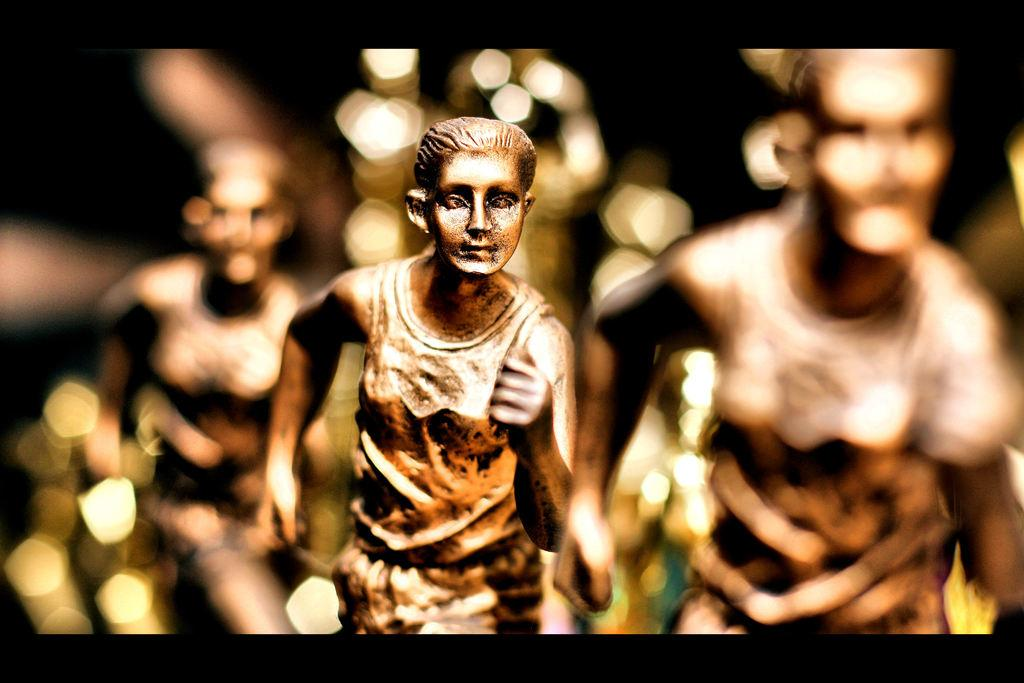What is the main subject in the foreground of the image? There are sculptures of persons in the foreground of the image. What are the sculptures doing? The sculptures appear to be running. Can you describe the background of the image? The background of the image is blurry. What type of reward can be seen hanging from the sculptures' feet in the image? There is no reward hanging from the sculptures' feet in the image; the sculptures are running without any visible rewards. 